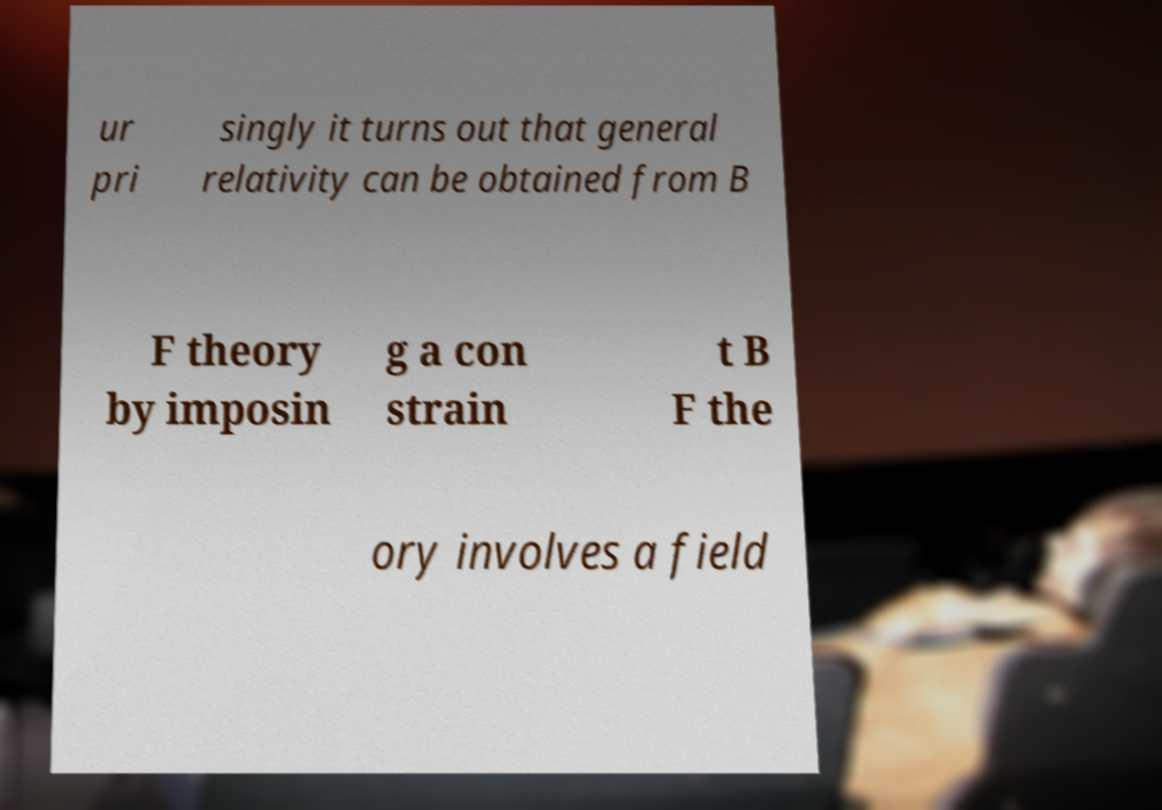Could you assist in decoding the text presented in this image and type it out clearly? ur pri singly it turns out that general relativity can be obtained from B F theory by imposin g a con strain t B F the ory involves a field 